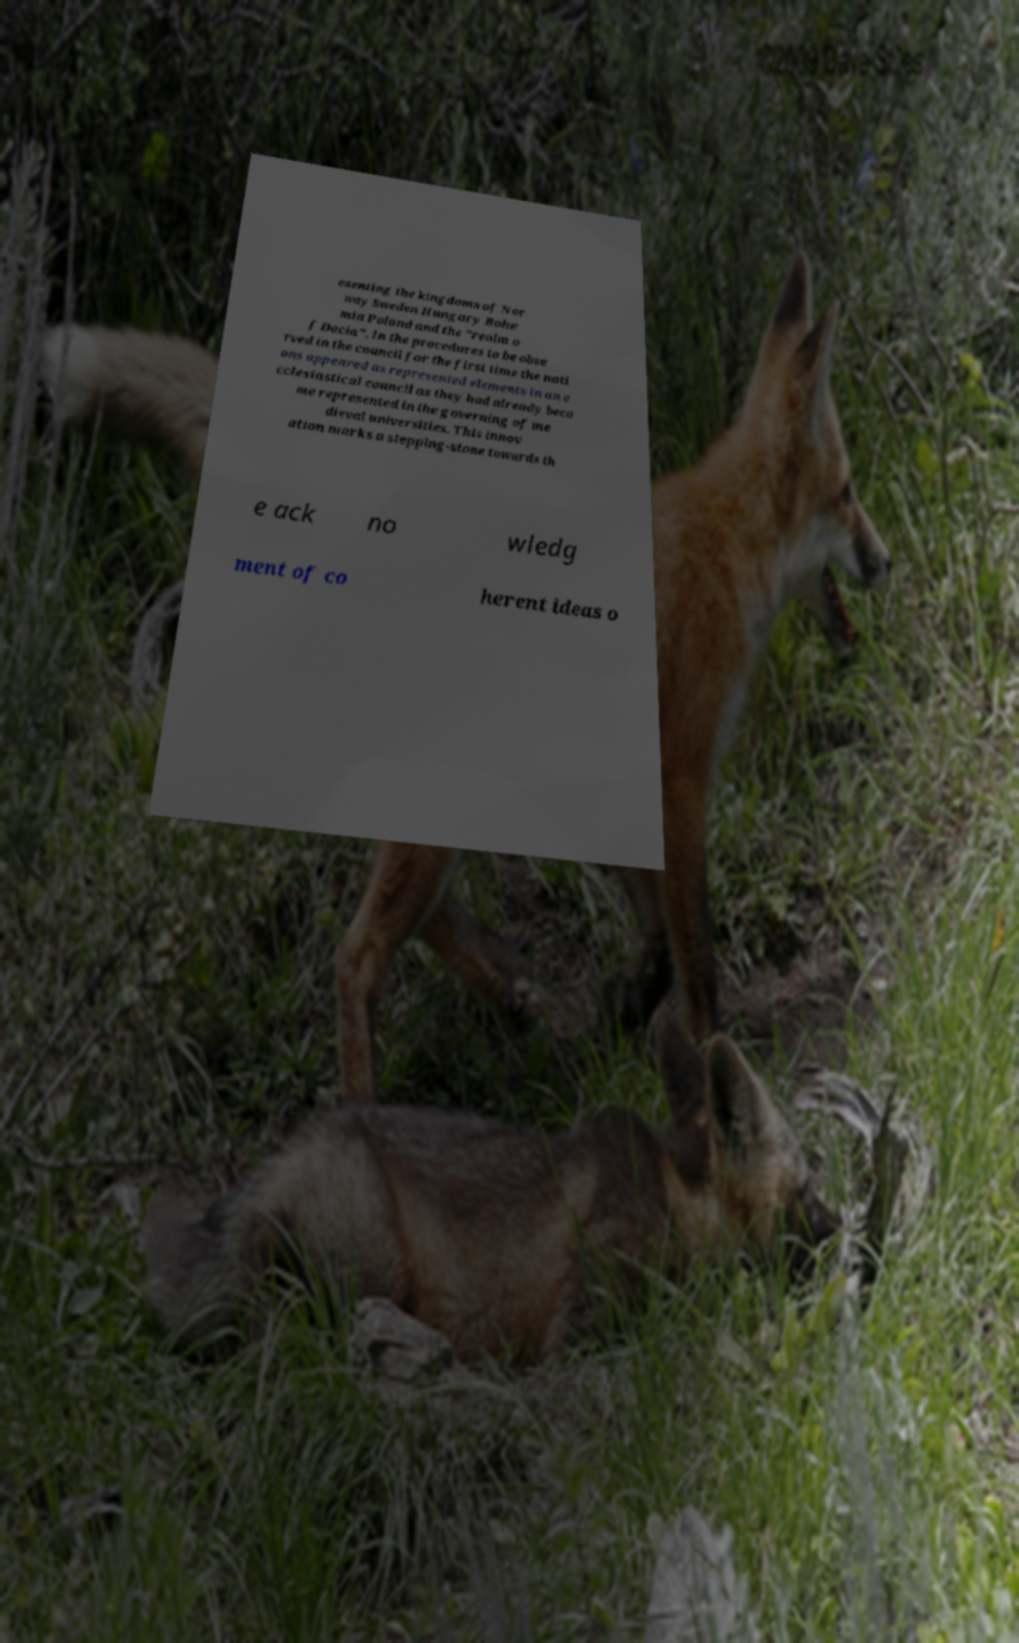Could you extract and type out the text from this image? esenting the kingdoms of Nor way Sweden Hungary Bohe mia Poland and the "realm o f Dacia". In the procedures to be obse rved in the council for the first time the nati ons appeared as represented elements in an e cclesiastical council as they had already beco me represented in the governing of me dieval universities. This innov ation marks a stepping-stone towards th e ack no wledg ment of co herent ideas o 